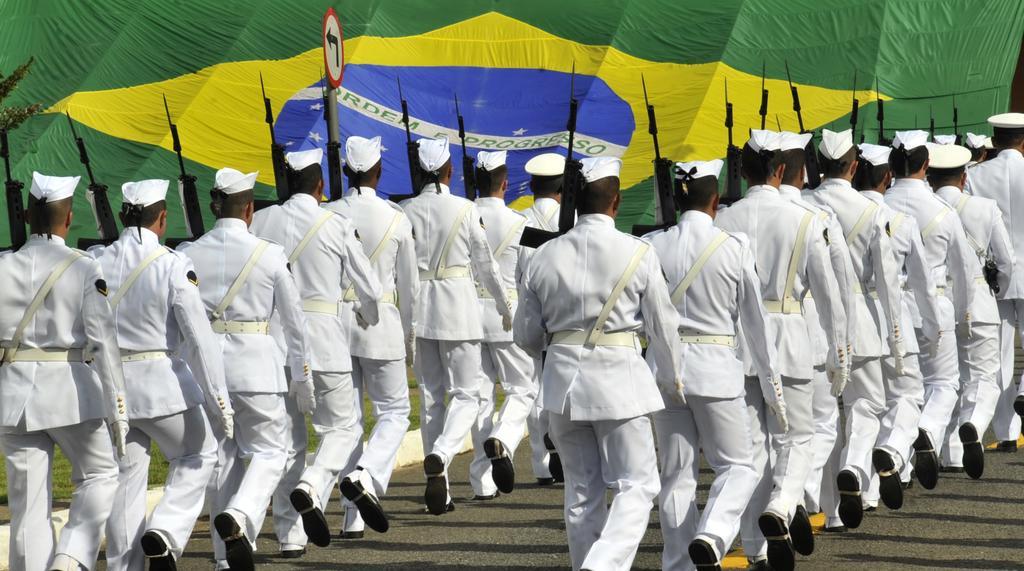How would you summarize this image in a sentence or two? In this picture we can see some people are wearing white color dresses and holding guns, they are walking on a land, behind we can see one flag and tree. 